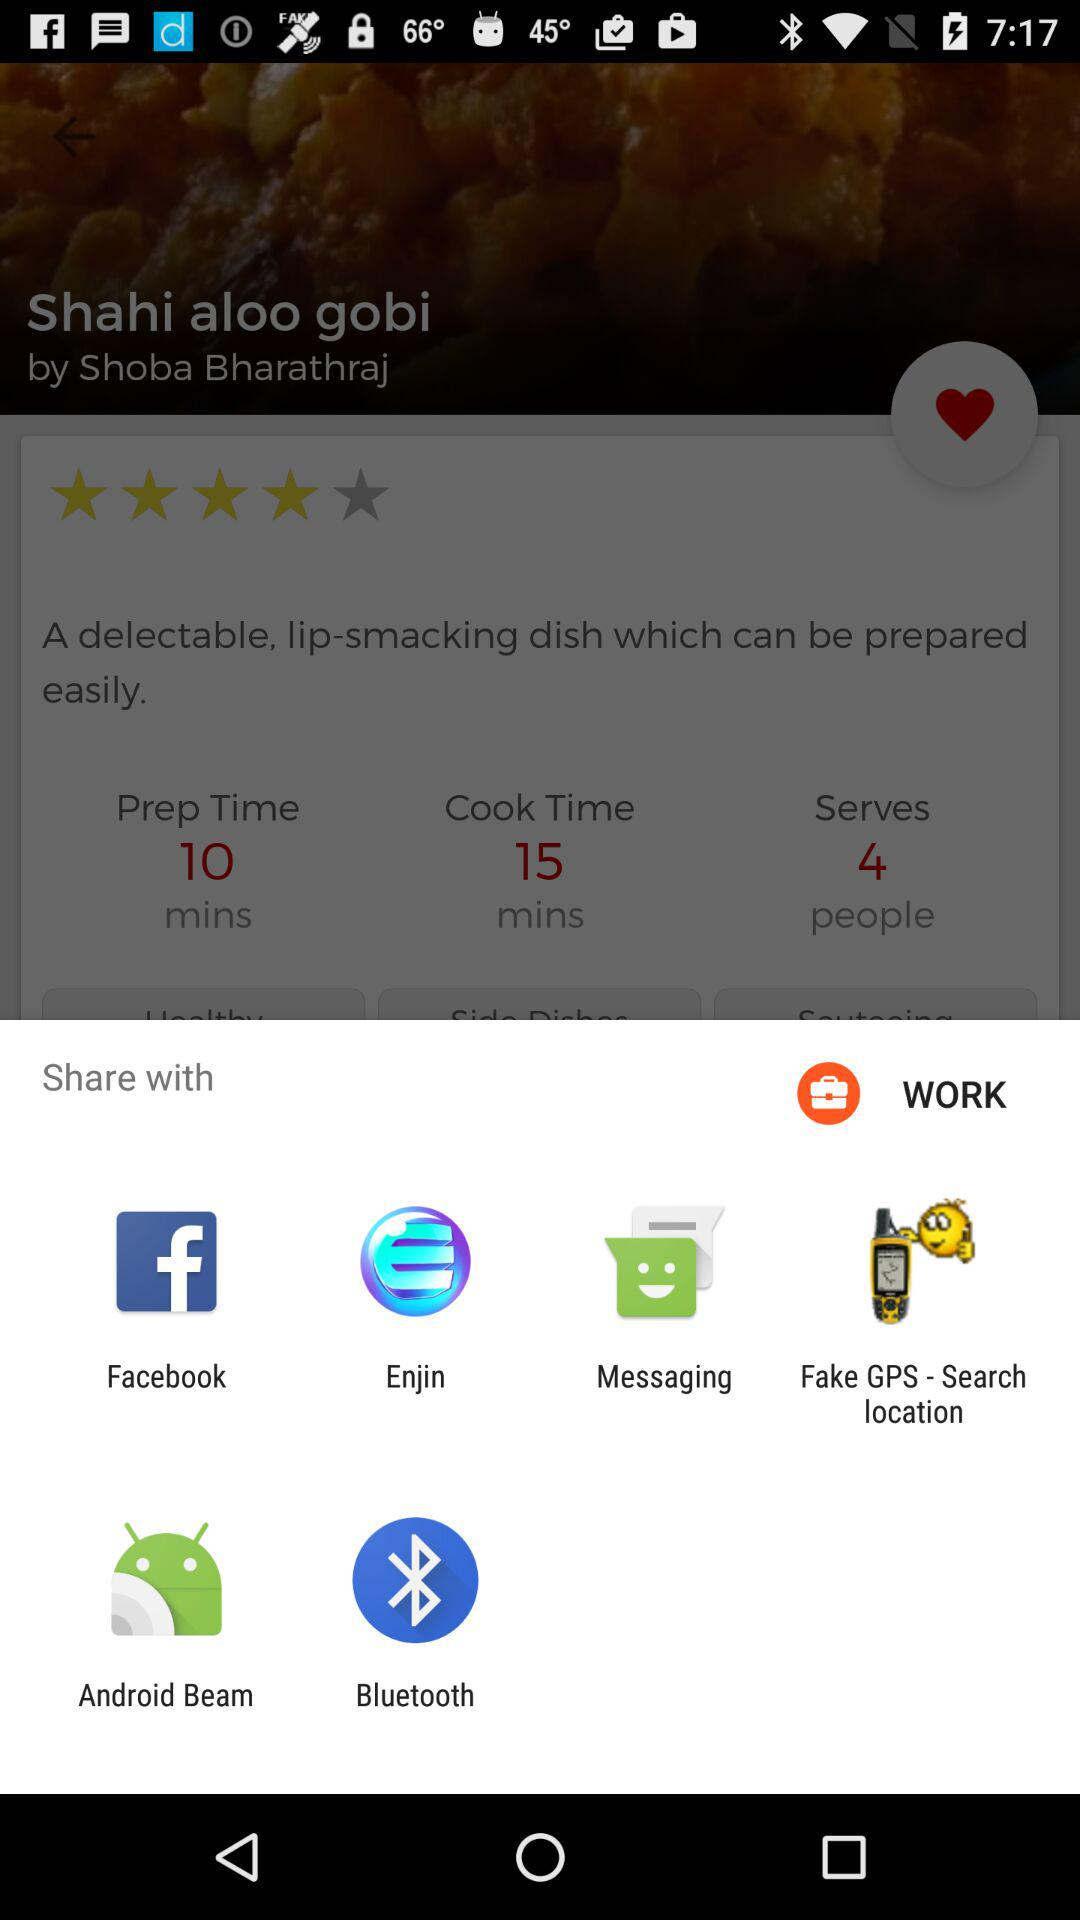Who is the chef of Shahi aloo gobi? The chef is Shoba Bharathraj. 